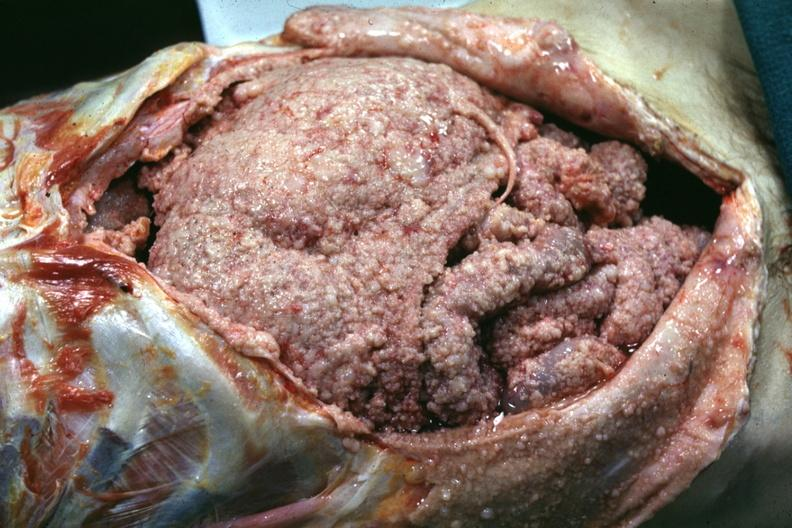s slices of liver and spleen typical tuberculous exudate is present on capsule of liver and spleen present?
Answer the question using a single word or phrase. No 